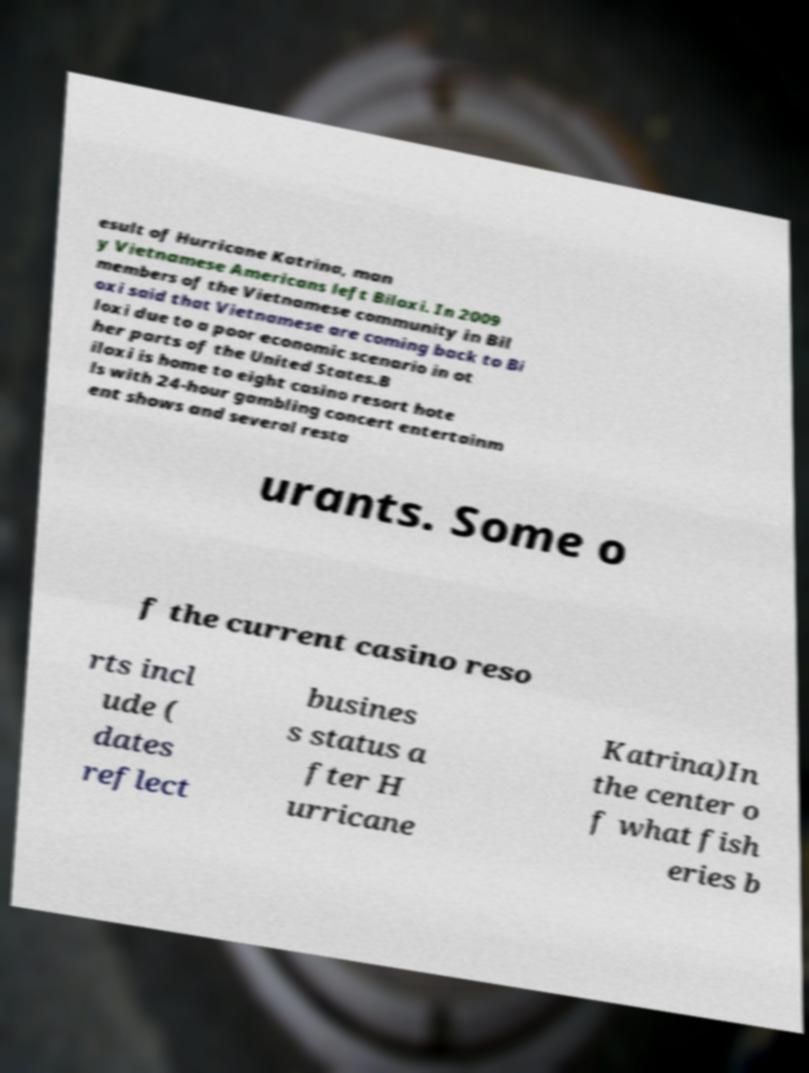There's text embedded in this image that I need extracted. Can you transcribe it verbatim? esult of Hurricane Katrina, man y Vietnamese Americans left Biloxi. In 2009 members of the Vietnamese community in Bil oxi said that Vietnamese are coming back to Bi loxi due to a poor economic scenario in ot her parts of the United States.B iloxi is home to eight casino resort hote ls with 24-hour gambling concert entertainm ent shows and several resta urants. Some o f the current casino reso rts incl ude ( dates reflect busines s status a fter H urricane Katrina)In the center o f what fish eries b 